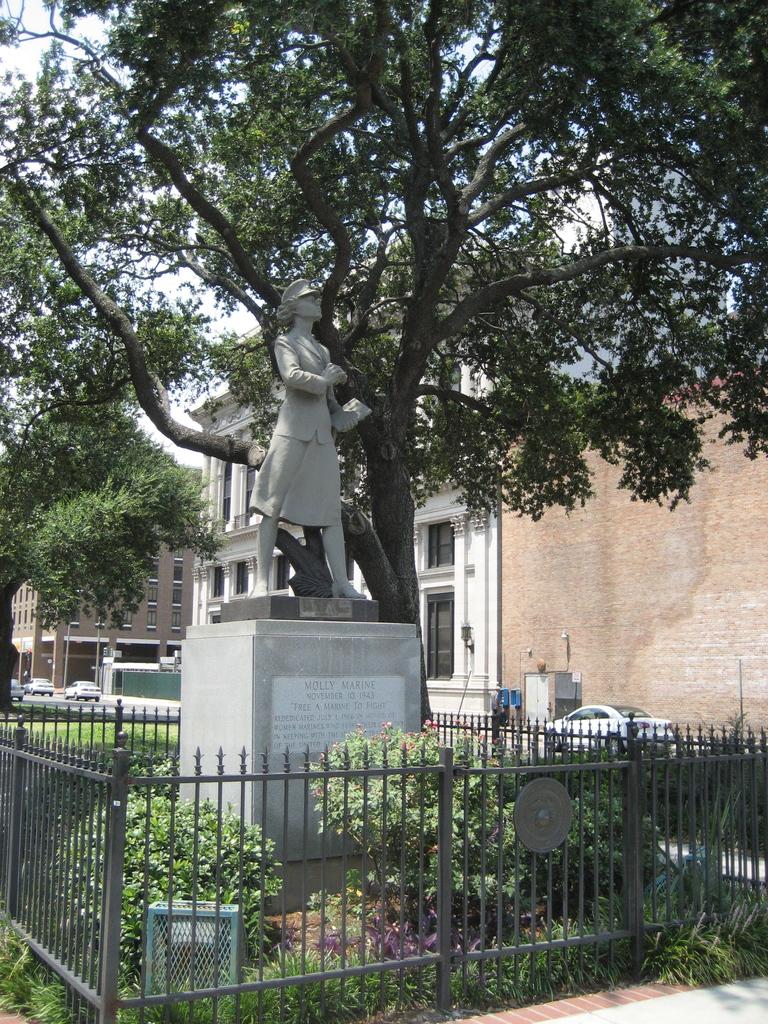What is the name of the monument?
Provide a short and direct response. Molly marine. What does the white plate say?
Keep it short and to the point. Unanswerable. 